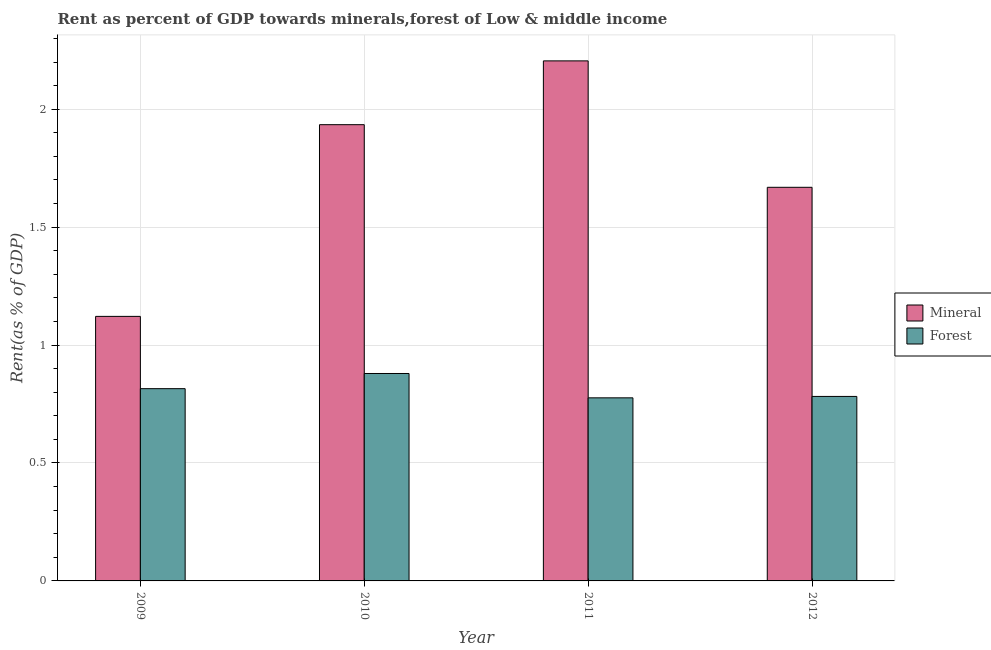How many different coloured bars are there?
Give a very brief answer. 2. How many groups of bars are there?
Your answer should be compact. 4. Are the number of bars per tick equal to the number of legend labels?
Provide a short and direct response. Yes. How many bars are there on the 4th tick from the left?
Provide a short and direct response. 2. What is the mineral rent in 2010?
Make the answer very short. 1.93. Across all years, what is the maximum forest rent?
Offer a very short reply. 0.88. Across all years, what is the minimum mineral rent?
Offer a very short reply. 1.12. In which year was the forest rent minimum?
Ensure brevity in your answer.  2011. What is the total forest rent in the graph?
Ensure brevity in your answer.  3.25. What is the difference between the forest rent in 2010 and that in 2012?
Provide a short and direct response. 0.1. What is the difference between the forest rent in 2009 and the mineral rent in 2010?
Provide a succinct answer. -0.06. What is the average forest rent per year?
Provide a succinct answer. 0.81. In the year 2011, what is the difference between the forest rent and mineral rent?
Offer a terse response. 0. In how many years, is the forest rent greater than 1 %?
Offer a terse response. 0. What is the ratio of the forest rent in 2010 to that in 2012?
Your response must be concise. 1.12. Is the forest rent in 2011 less than that in 2012?
Provide a succinct answer. Yes. What is the difference between the highest and the second highest forest rent?
Offer a very short reply. 0.06. What is the difference between the highest and the lowest mineral rent?
Your answer should be very brief. 1.08. Is the sum of the mineral rent in 2009 and 2012 greater than the maximum forest rent across all years?
Keep it short and to the point. Yes. What does the 1st bar from the left in 2012 represents?
Give a very brief answer. Mineral. What does the 1st bar from the right in 2010 represents?
Ensure brevity in your answer.  Forest. How many bars are there?
Give a very brief answer. 8. Are the values on the major ticks of Y-axis written in scientific E-notation?
Provide a short and direct response. No. Does the graph contain any zero values?
Provide a succinct answer. No. How many legend labels are there?
Offer a very short reply. 2. How are the legend labels stacked?
Offer a terse response. Vertical. What is the title of the graph?
Ensure brevity in your answer.  Rent as percent of GDP towards minerals,forest of Low & middle income. What is the label or title of the Y-axis?
Your response must be concise. Rent(as % of GDP). What is the Rent(as % of GDP) of Mineral in 2009?
Ensure brevity in your answer.  1.12. What is the Rent(as % of GDP) in Forest in 2009?
Your answer should be very brief. 0.82. What is the Rent(as % of GDP) in Mineral in 2010?
Give a very brief answer. 1.93. What is the Rent(as % of GDP) in Forest in 2010?
Provide a short and direct response. 0.88. What is the Rent(as % of GDP) of Mineral in 2011?
Make the answer very short. 2.21. What is the Rent(as % of GDP) of Forest in 2011?
Keep it short and to the point. 0.78. What is the Rent(as % of GDP) in Mineral in 2012?
Provide a short and direct response. 1.67. What is the Rent(as % of GDP) of Forest in 2012?
Make the answer very short. 0.78. Across all years, what is the maximum Rent(as % of GDP) of Mineral?
Provide a short and direct response. 2.21. Across all years, what is the maximum Rent(as % of GDP) in Forest?
Offer a terse response. 0.88. Across all years, what is the minimum Rent(as % of GDP) in Mineral?
Offer a terse response. 1.12. Across all years, what is the minimum Rent(as % of GDP) of Forest?
Give a very brief answer. 0.78. What is the total Rent(as % of GDP) of Mineral in the graph?
Provide a short and direct response. 6.93. What is the total Rent(as % of GDP) in Forest in the graph?
Your answer should be compact. 3.25. What is the difference between the Rent(as % of GDP) in Mineral in 2009 and that in 2010?
Give a very brief answer. -0.81. What is the difference between the Rent(as % of GDP) of Forest in 2009 and that in 2010?
Make the answer very short. -0.06. What is the difference between the Rent(as % of GDP) in Mineral in 2009 and that in 2011?
Your answer should be compact. -1.08. What is the difference between the Rent(as % of GDP) of Forest in 2009 and that in 2011?
Your answer should be compact. 0.04. What is the difference between the Rent(as % of GDP) of Mineral in 2009 and that in 2012?
Ensure brevity in your answer.  -0.55. What is the difference between the Rent(as % of GDP) in Forest in 2009 and that in 2012?
Provide a short and direct response. 0.03. What is the difference between the Rent(as % of GDP) in Mineral in 2010 and that in 2011?
Your response must be concise. -0.27. What is the difference between the Rent(as % of GDP) in Forest in 2010 and that in 2011?
Keep it short and to the point. 0.1. What is the difference between the Rent(as % of GDP) of Mineral in 2010 and that in 2012?
Offer a very short reply. 0.27. What is the difference between the Rent(as % of GDP) in Forest in 2010 and that in 2012?
Give a very brief answer. 0.1. What is the difference between the Rent(as % of GDP) in Mineral in 2011 and that in 2012?
Provide a succinct answer. 0.54. What is the difference between the Rent(as % of GDP) of Forest in 2011 and that in 2012?
Offer a very short reply. -0.01. What is the difference between the Rent(as % of GDP) of Mineral in 2009 and the Rent(as % of GDP) of Forest in 2010?
Ensure brevity in your answer.  0.24. What is the difference between the Rent(as % of GDP) of Mineral in 2009 and the Rent(as % of GDP) of Forest in 2011?
Offer a very short reply. 0.35. What is the difference between the Rent(as % of GDP) in Mineral in 2009 and the Rent(as % of GDP) in Forest in 2012?
Provide a short and direct response. 0.34. What is the difference between the Rent(as % of GDP) in Mineral in 2010 and the Rent(as % of GDP) in Forest in 2011?
Offer a terse response. 1.16. What is the difference between the Rent(as % of GDP) in Mineral in 2010 and the Rent(as % of GDP) in Forest in 2012?
Your answer should be very brief. 1.15. What is the difference between the Rent(as % of GDP) of Mineral in 2011 and the Rent(as % of GDP) of Forest in 2012?
Give a very brief answer. 1.42. What is the average Rent(as % of GDP) of Mineral per year?
Offer a very short reply. 1.73. What is the average Rent(as % of GDP) of Forest per year?
Make the answer very short. 0.81. In the year 2009, what is the difference between the Rent(as % of GDP) of Mineral and Rent(as % of GDP) of Forest?
Your answer should be compact. 0.31. In the year 2010, what is the difference between the Rent(as % of GDP) of Mineral and Rent(as % of GDP) of Forest?
Ensure brevity in your answer.  1.05. In the year 2011, what is the difference between the Rent(as % of GDP) of Mineral and Rent(as % of GDP) of Forest?
Offer a very short reply. 1.43. In the year 2012, what is the difference between the Rent(as % of GDP) of Mineral and Rent(as % of GDP) of Forest?
Your answer should be very brief. 0.89. What is the ratio of the Rent(as % of GDP) of Mineral in 2009 to that in 2010?
Your answer should be very brief. 0.58. What is the ratio of the Rent(as % of GDP) in Forest in 2009 to that in 2010?
Provide a short and direct response. 0.93. What is the ratio of the Rent(as % of GDP) of Mineral in 2009 to that in 2011?
Make the answer very short. 0.51. What is the ratio of the Rent(as % of GDP) in Forest in 2009 to that in 2011?
Give a very brief answer. 1.05. What is the ratio of the Rent(as % of GDP) in Mineral in 2009 to that in 2012?
Offer a terse response. 0.67. What is the ratio of the Rent(as % of GDP) of Forest in 2009 to that in 2012?
Your response must be concise. 1.04. What is the ratio of the Rent(as % of GDP) of Mineral in 2010 to that in 2011?
Provide a succinct answer. 0.88. What is the ratio of the Rent(as % of GDP) in Forest in 2010 to that in 2011?
Give a very brief answer. 1.13. What is the ratio of the Rent(as % of GDP) in Mineral in 2010 to that in 2012?
Provide a short and direct response. 1.16. What is the ratio of the Rent(as % of GDP) of Forest in 2010 to that in 2012?
Ensure brevity in your answer.  1.12. What is the ratio of the Rent(as % of GDP) of Mineral in 2011 to that in 2012?
Your response must be concise. 1.32. What is the difference between the highest and the second highest Rent(as % of GDP) of Mineral?
Offer a terse response. 0.27. What is the difference between the highest and the second highest Rent(as % of GDP) in Forest?
Your answer should be very brief. 0.06. What is the difference between the highest and the lowest Rent(as % of GDP) in Mineral?
Your response must be concise. 1.08. What is the difference between the highest and the lowest Rent(as % of GDP) in Forest?
Make the answer very short. 0.1. 